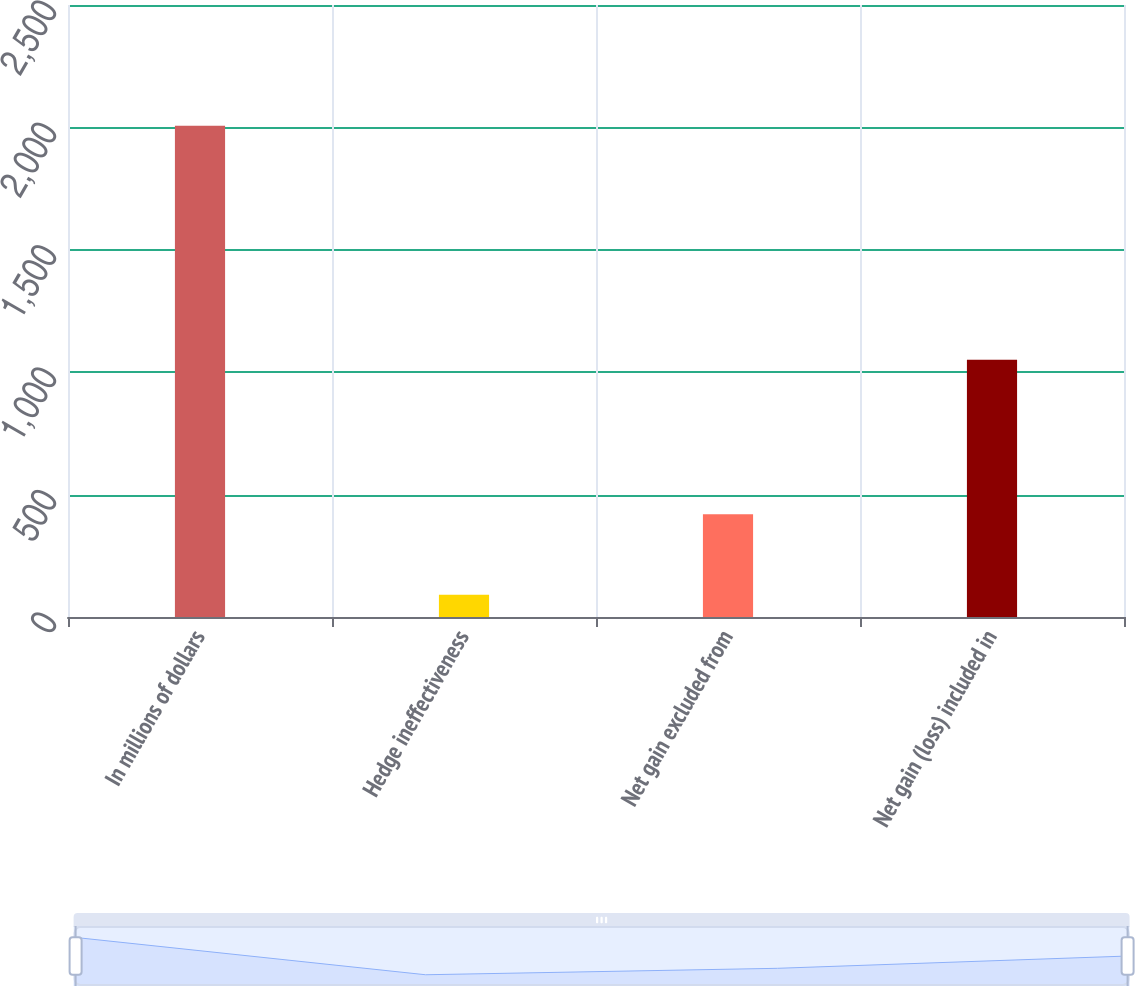Convert chart. <chart><loc_0><loc_0><loc_500><loc_500><bar_chart><fcel>In millions of dollars<fcel>Hedge ineffectiveness<fcel>Net gain excluded from<fcel>Net gain (loss) included in<nl><fcel>2007<fcel>91<fcel>420<fcel>1051<nl></chart> 